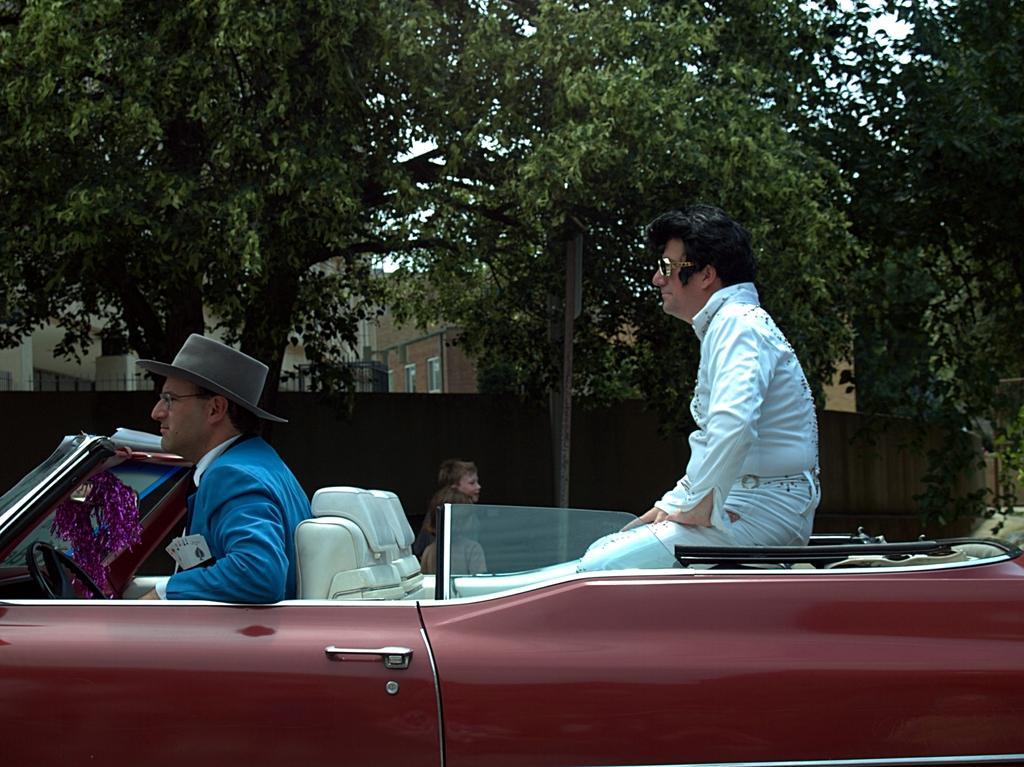Can you describe this image briefly? In this image there are two person sitting in a car, person in the left side wearing a blue colour suit and a hat is on the steering and a person at the right side is wearing a white colour shirt. In the background there are two children a wall, building with a red colour bricks and some trees. 